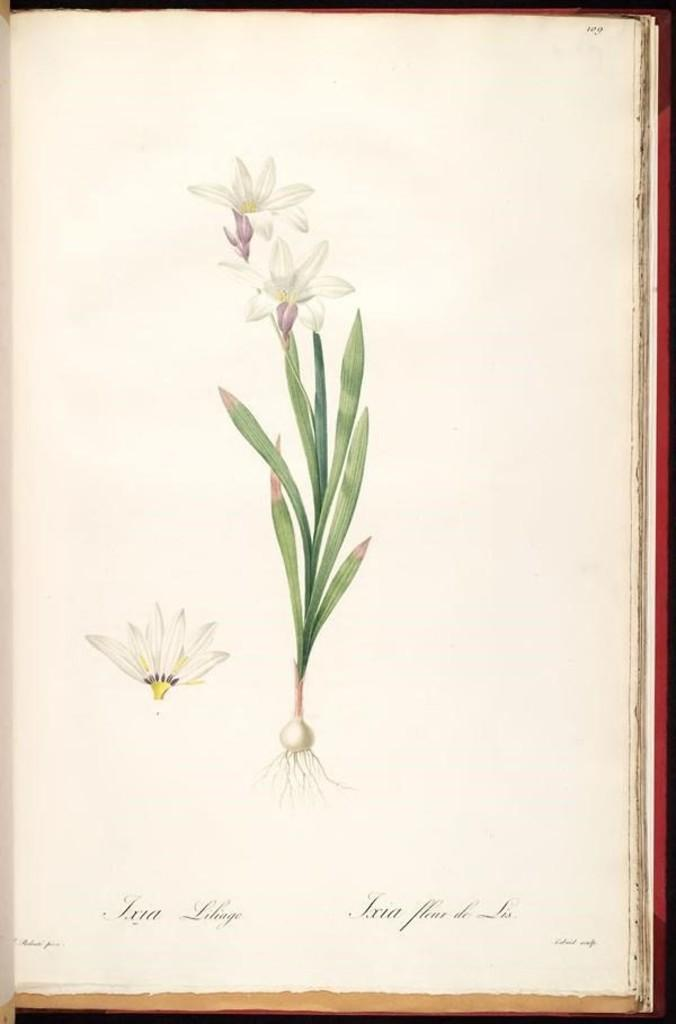What type of plant parts can be seen in the image? The image contains flowers, stems, leaves, and roots. What other elements are present in the image besides plant parts? There is text present in the image. How much money is being exchanged in the image? There is no money present in the image; it contains plant parts and text. What type of club can be seen in the image? There is no club present in the image; it contains plant parts and text. 